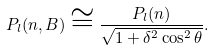<formula> <loc_0><loc_0><loc_500><loc_500>P _ { l } ( { n } , { B } ) \cong \frac { P _ { l } ( { n } ) } { \sqrt { 1 + \delta ^ { 2 } \cos ^ { 2 } \theta } } .</formula> 